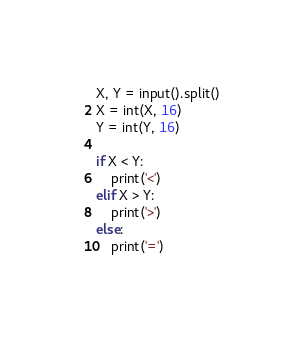Convert code to text. <code><loc_0><loc_0><loc_500><loc_500><_Python_>X, Y = input().split()
X = int(X, 16)
Y = int(Y, 16)

if X < Y:
    print('<')
elif X > Y:
    print('>')
else:
    print('=')</code> 